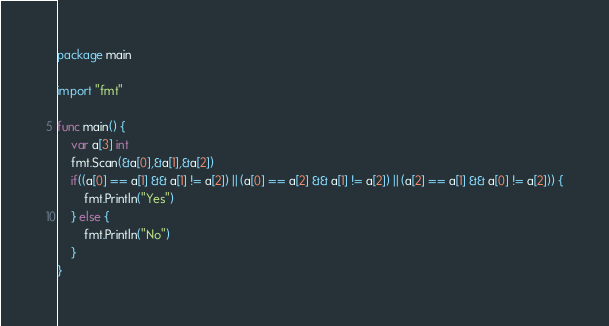<code> <loc_0><loc_0><loc_500><loc_500><_Go_>package main

import "fmt"

func main() {
	var a[3] int
	fmt.Scan(&a[0],&a[1],&a[2])
	if((a[0] == a[1] && a[1] != a[2]) || (a[0] == a[2] && a[1] != a[2]) || (a[2] == a[1] && a[0] != a[2])) {
		fmt.Println("Yes")
	} else {
		fmt.Println("No")
	}
}</code> 